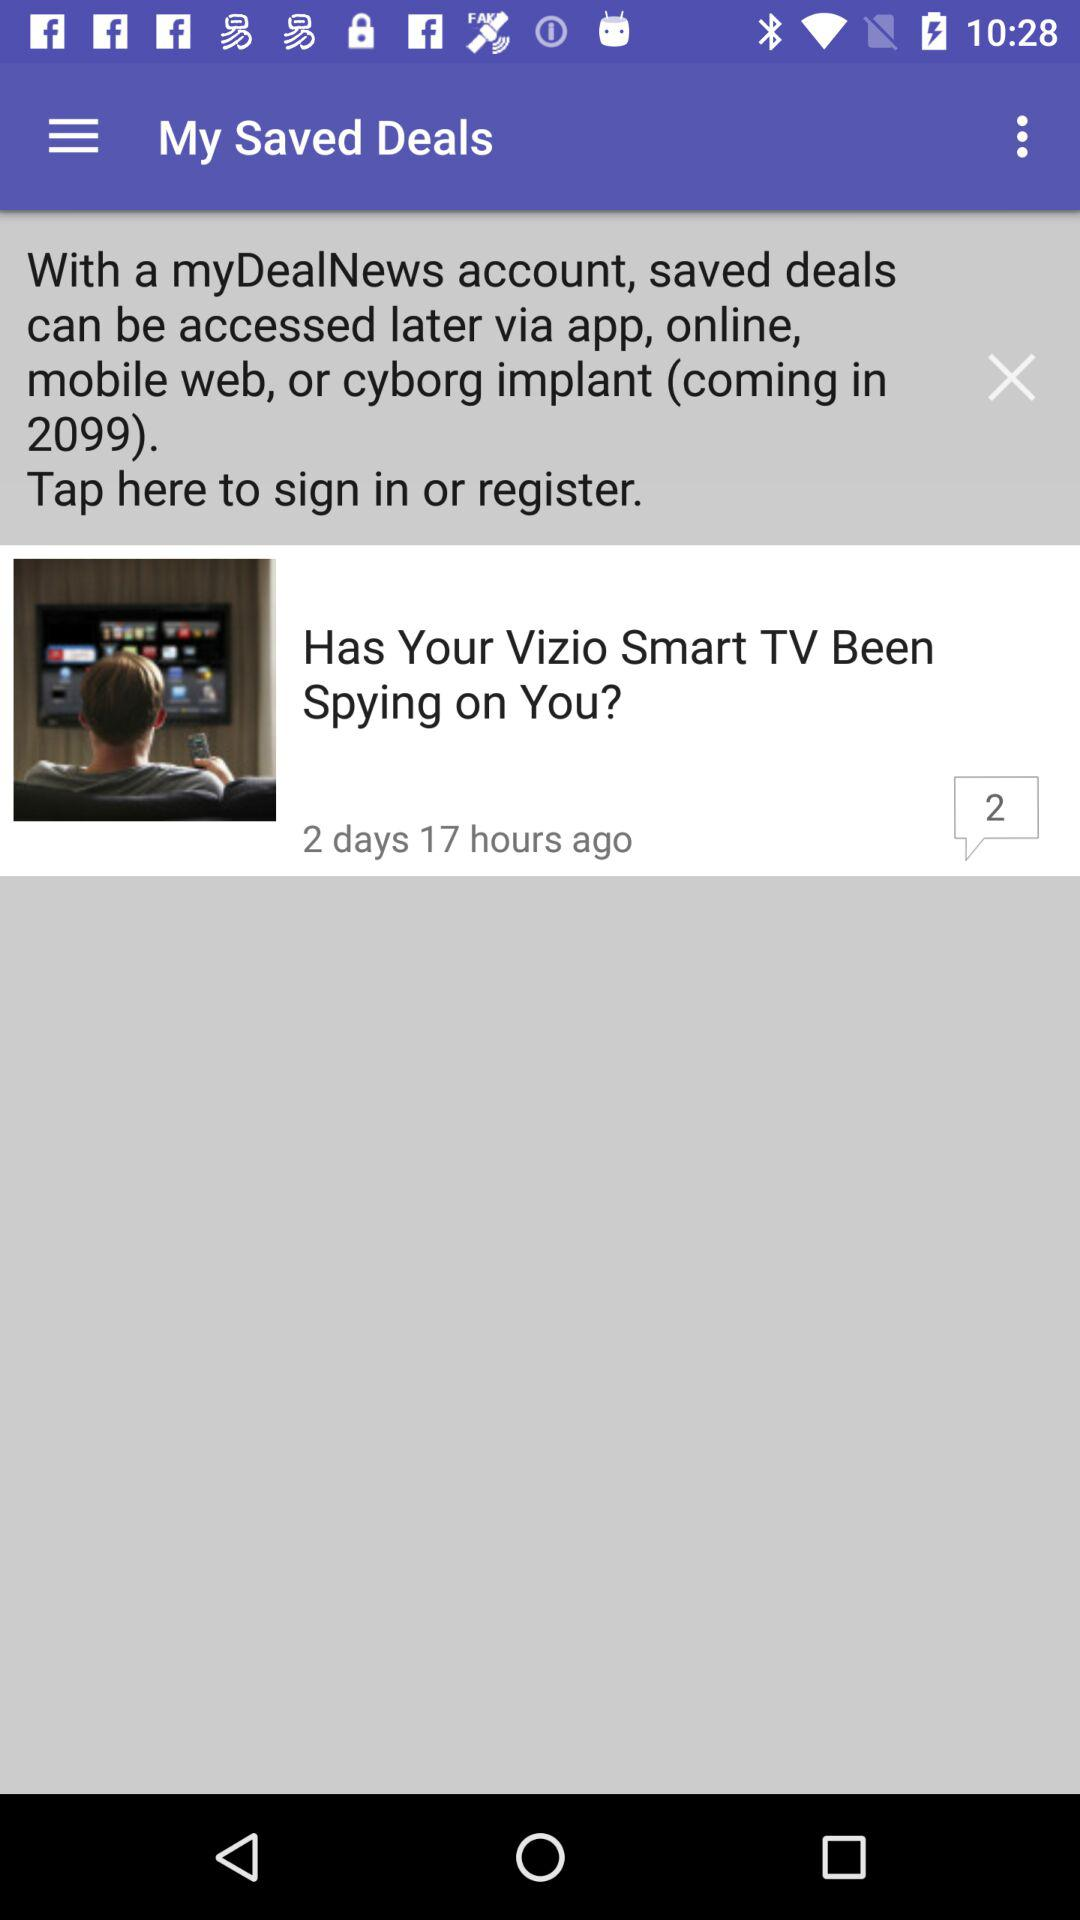How many comments are there for "Has Your Vizio Smart TV Been Spying on You?"? There are two comments. 